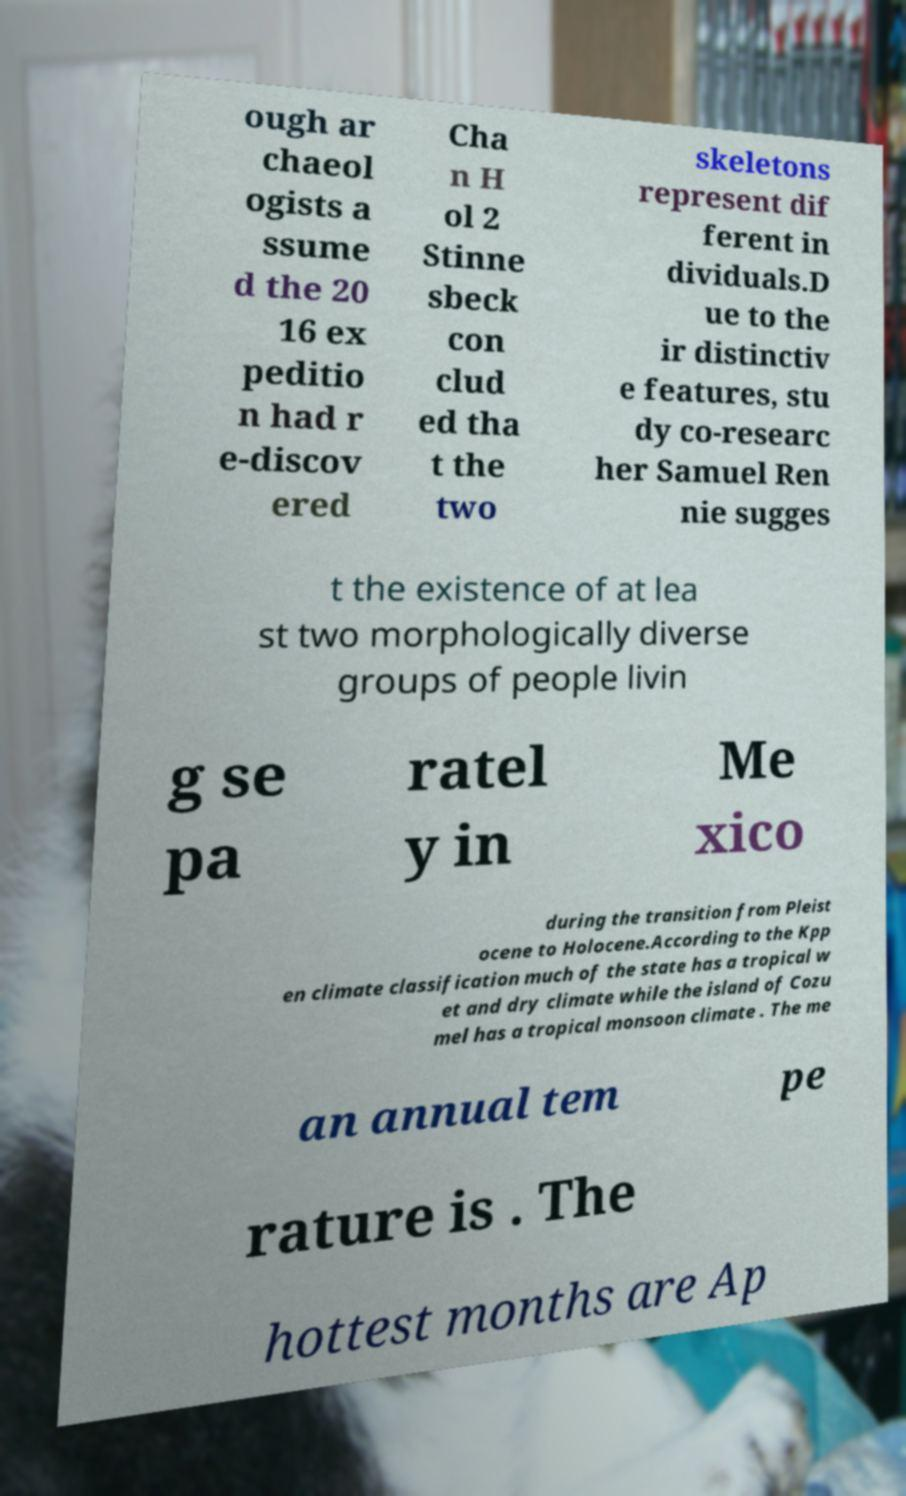I need the written content from this picture converted into text. Can you do that? ough ar chaeol ogists a ssume d the 20 16 ex peditio n had r e-discov ered Cha n H ol 2 Stinne sbeck con clud ed tha t the two skeletons represent dif ferent in dividuals.D ue to the ir distinctiv e features, stu dy co-researc her Samuel Ren nie sugges t the existence of at lea st two morphologically diverse groups of people livin g se pa ratel y in Me xico during the transition from Pleist ocene to Holocene.According to the Kpp en climate classification much of the state has a tropical w et and dry climate while the island of Cozu mel has a tropical monsoon climate . The me an annual tem pe rature is . The hottest months are Ap 